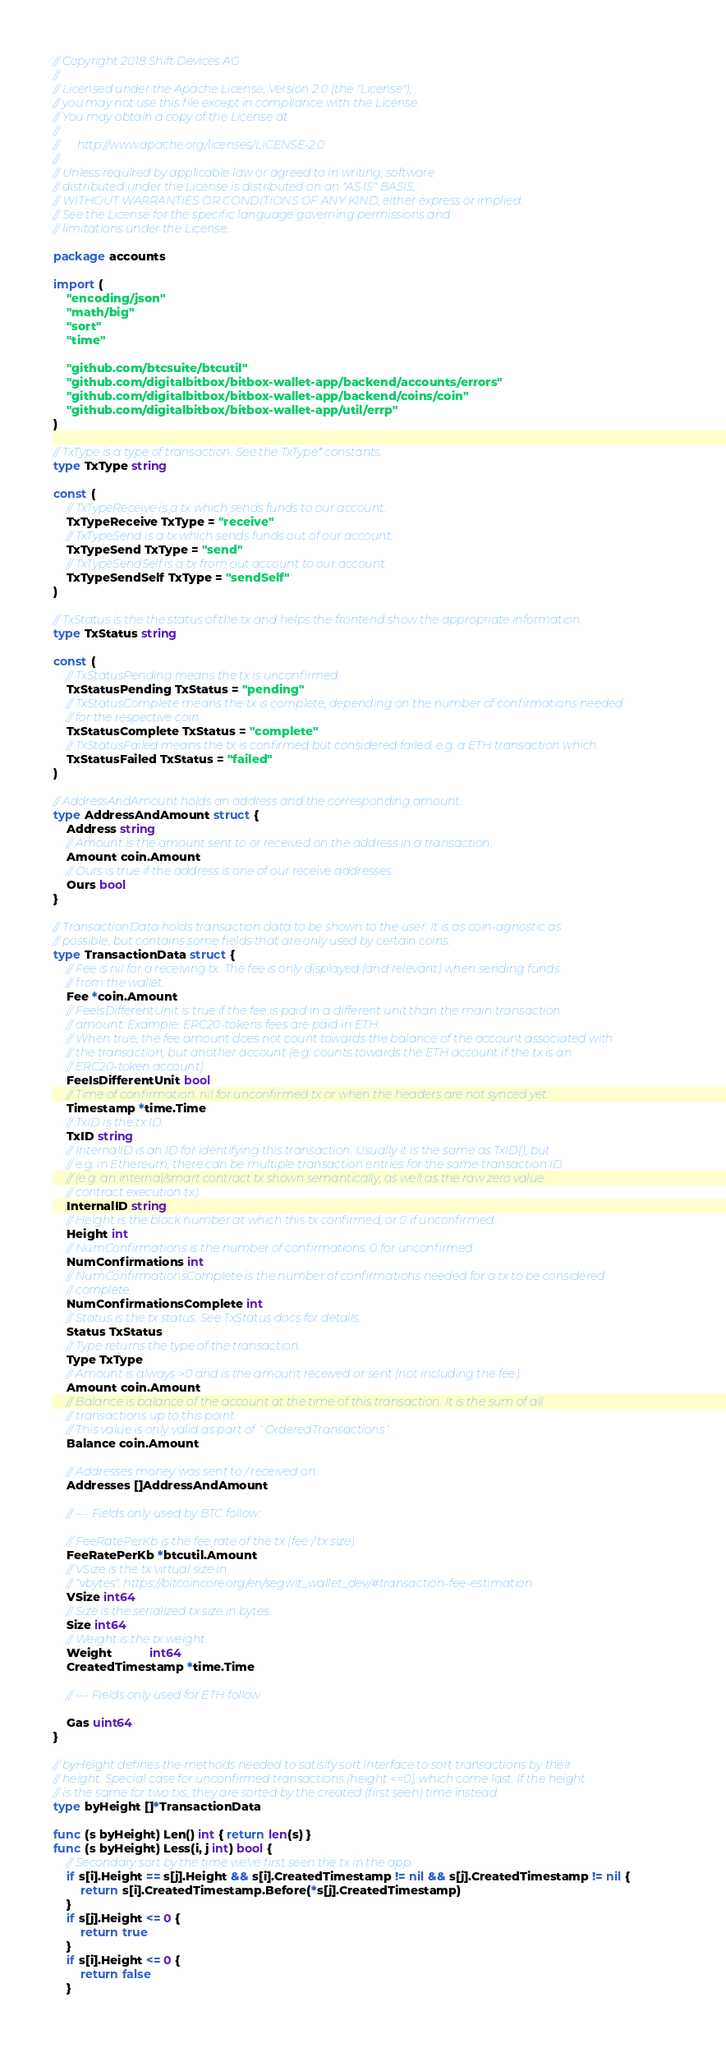Convert code to text. <code><loc_0><loc_0><loc_500><loc_500><_Go_>// Copyright 2018 Shift Devices AG
//
// Licensed under the Apache License, Version 2.0 (the "License");
// you may not use this file except in compliance with the License.
// You may obtain a copy of the License at
//
//      http://www.apache.org/licenses/LICENSE-2.0
//
// Unless required by applicable law or agreed to in writing, software
// distributed under the License is distributed on an "AS IS" BASIS,
// WITHOUT WARRANTIES OR CONDITIONS OF ANY KIND, either express or implied.
// See the License for the specific language governing permissions and
// limitations under the License.

package accounts

import (
	"encoding/json"
	"math/big"
	"sort"
	"time"

	"github.com/btcsuite/btcutil"
	"github.com/digitalbitbox/bitbox-wallet-app/backend/accounts/errors"
	"github.com/digitalbitbox/bitbox-wallet-app/backend/coins/coin"
	"github.com/digitalbitbox/bitbox-wallet-app/util/errp"
)

// TxType is a type of transaction. See the TxType* constants.
type TxType string

const (
	// TxTypeReceive is a tx which sends funds to our account.
	TxTypeReceive TxType = "receive"
	// TxTypeSend is a tx which sends funds out of our account.
	TxTypeSend TxType = "send"
	// TxTypeSendSelf is a tx from out account to our account.
	TxTypeSendSelf TxType = "sendSelf"
)

// TxStatus is the the status of the tx and helps the frontend show the appropriate information.
type TxStatus string

const (
	// TxStatusPending means the tx is unconfirmed.
	TxStatusPending TxStatus = "pending"
	// TxStatusComplete means the tx is complete, depending on the number of confirmations needed
	// for the respective coin.
	TxStatusComplete TxStatus = "complete"
	// TxStatusFailed means the tx is confirmed but considered failed, e.g. a ETH transaction which
	TxStatusFailed TxStatus = "failed"
)

// AddressAndAmount holds an address and the corresponding amount.
type AddressAndAmount struct {
	Address string
	// Amount is the amount sent to or received on the address in a transaction.
	Amount coin.Amount
	// Ours is true if the address is one of our receive addresses.
	Ours bool
}

// TransactionData holds transaction data to be shown to the user. It is as coin-agnostic as
// possible, but contains some fields that are only used by certain coins.
type TransactionData struct {
	// Fee is nil for a receiving tx. The fee is only displayed (and relevant) when sending funds
	// from the wallet.
	Fee *coin.Amount
	// FeeIsDifferentUnit is true if the fee is paid in a different unit than the main transaction
	// amount. Example: ERC20-tokens fees are paid in ETH.
	// When true, the fee amount does not count towards the balance of the account associated with
	// the transaction, but another account (e.g. counts towards the ETH account if the tx is an
	// ERC20-token account).
	FeeIsDifferentUnit bool
	// Time of confirmation. nil for unconfirmed tx or when the headers are not synced yet.
	Timestamp *time.Time
	// TxID is the tx ID.
	TxID string
	// InternalID is an ID for identifying this transaction. Usually it is the same as TxID(), but
	// e.g. in Ethereum, there can be multiple transaction entries for the same transaction ID
	// (e.g. an internal/smart contract tx shown semantically, as well as the raw zero value
	// contract execution tx).
	InternalID string
	// Height is the block number at which this tx confirmed, or 0 if unconfirmed.
	Height int
	// NumConfirmations is the number of confirmations. 0 for unconfirmed.
	NumConfirmations int
	// NumConfirmationsComplete is the number of confirmations needed for a tx to be considered
	// complete.
	NumConfirmationsComplete int
	// Status is the tx status. See TxStatus docs for details.
	Status TxStatus
	// Type returns the type of the transaction.
	Type TxType
	// Amount is always >0 and is the amount received or sent (not including the fee).
	Amount coin.Amount
	// Balance is balance of the account at the time of this transaction. It is the sum of all
	// transactions up to this point.
	// This value is only valid as part of `OrderedTransactions`.
	Balance coin.Amount

	// Addresses money was sent to / received on.
	Addresses []AddressAndAmount

	// --- Fields only used by BTC follow:

	// FeeRatePerKb is the fee rate of the tx (fee / tx size).
	FeeRatePerKb *btcutil.Amount
	// VSize is the tx virtual size in
	// "vbytes". https://bitcoincore.org/en/segwit_wallet_dev/#transaction-fee-estimation
	VSize int64
	// Size is the serialized tx size in bytes.
	Size int64
	// Weight is the tx weight.
	Weight           int64
	CreatedTimestamp *time.Time

	// --- Fields only used for ETH follow

	Gas uint64
}

// byHeight defines the methods needed to satisify sort.Interface to sort transactions by their
// height. Special case for unconfirmed transactions (height <=0), which come last. If the height
// is the same for two txs, they are sorted by the created (first seen) time instead.
type byHeight []*TransactionData

func (s byHeight) Len() int { return len(s) }
func (s byHeight) Less(i, j int) bool {
	// Secondary sort by the time we've first seen the tx in the app.
	if s[i].Height == s[j].Height && s[i].CreatedTimestamp != nil && s[j].CreatedTimestamp != nil {
		return s[i].CreatedTimestamp.Before(*s[j].CreatedTimestamp)
	}
	if s[j].Height <= 0 {
		return true
	}
	if s[i].Height <= 0 {
		return false
	}</code> 